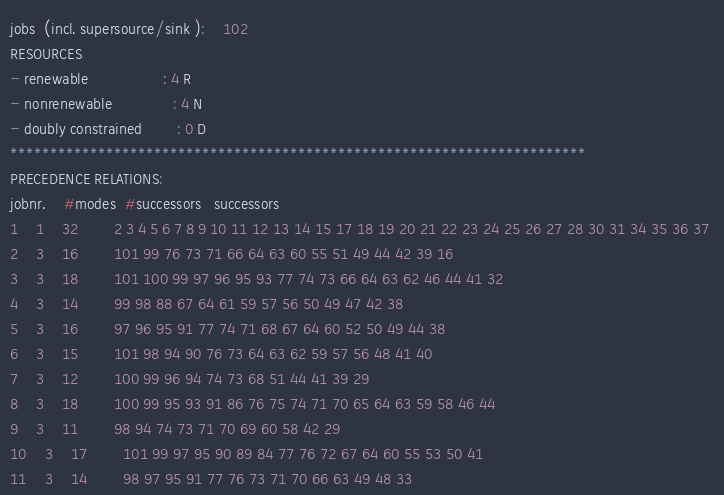Convert code to text. <code><loc_0><loc_0><loc_500><loc_500><_ObjectiveC_>jobs  (incl. supersource/sink ):	102
RESOURCES
- renewable                 : 4 R
- nonrenewable              : 4 N
- doubly constrained        : 0 D
************************************************************************
PRECEDENCE RELATIONS:
jobnr.    #modes  #successors   successors
1	1	32		2 3 4 5 6 7 8 9 10 11 12 13 14 15 17 18 19 20 21 22 23 24 25 26 27 28 30 31 34 35 36 37 
2	3	16		101 99 76 73 71 66 64 63 60 55 51 49 44 42 39 16 
3	3	18		101 100 99 97 96 95 93 77 74 73 66 64 63 62 46 44 41 32 
4	3	14		99 98 88 67 64 61 59 57 56 50 49 47 42 38 
5	3	16		97 96 95 91 77 74 71 68 67 64 60 52 50 49 44 38 
6	3	15		101 98 94 90 76 73 64 63 62 59 57 56 48 41 40 
7	3	12		100 99 96 94 74 73 68 51 44 41 39 29 
8	3	18		100 99 95 93 91 86 76 75 74 71 70 65 64 63 59 58 46 44 
9	3	11		98 94 74 73 71 70 69 60 58 42 29 
10	3	17		101 99 97 95 90 89 84 77 76 72 67 64 60 55 53 50 41 
11	3	14		98 97 95 91 77 76 73 71 70 66 63 49 48 33 </code> 